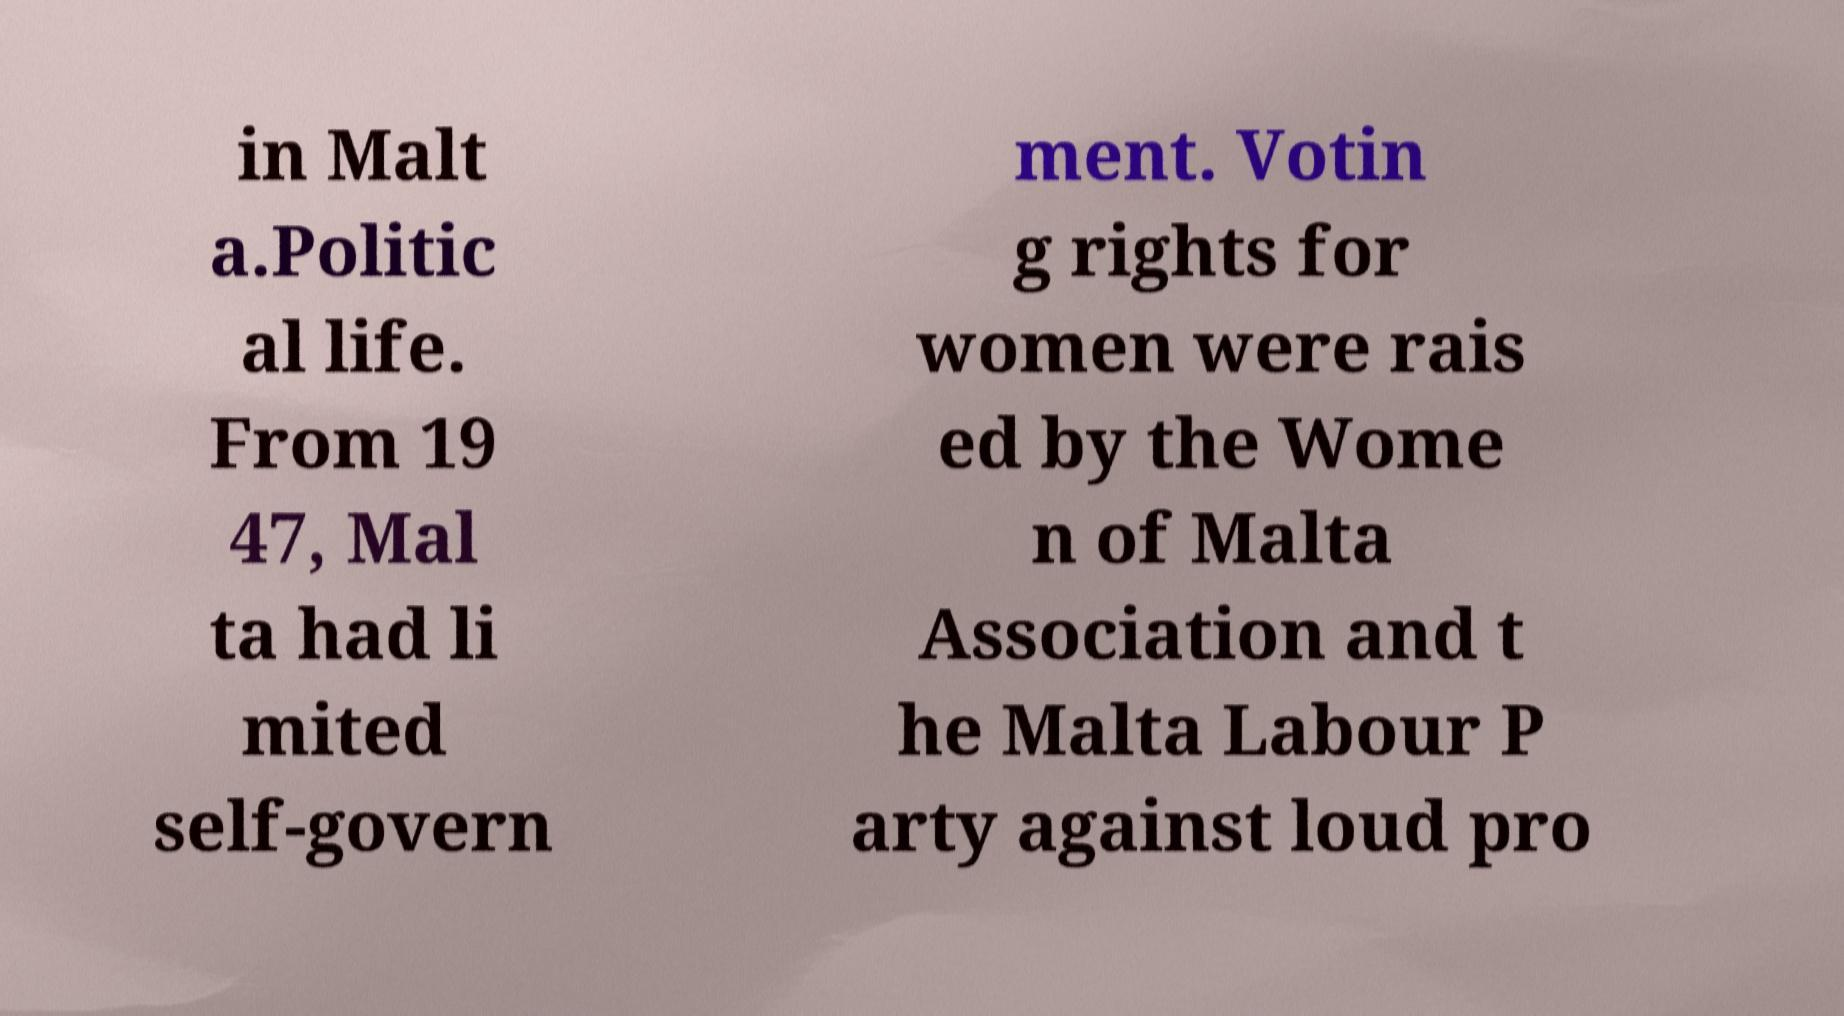I need the written content from this picture converted into text. Can you do that? in Malt a.Politic al life. From 19 47, Mal ta had li mited self-govern ment. Votin g rights for women were rais ed by the Wome n of Malta Association and t he Malta Labour P arty against loud pro 